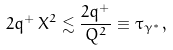Convert formula to latex. <formula><loc_0><loc_0><loc_500><loc_500>2 q ^ { + } \, X ^ { 2 } \lesssim \frac { 2 q ^ { + } } { Q ^ { 2 } } \equiv \tau _ { \gamma ^ { * } } \, ,</formula> 